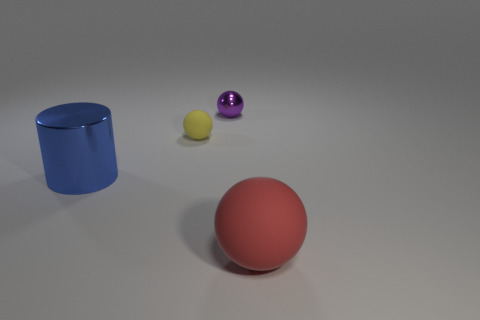Add 1 cyan cylinders. How many objects exist? 5 Subtract all rubber balls. How many balls are left? 1 Subtract all spheres. How many objects are left? 1 Add 1 metal things. How many metal things exist? 3 Subtract 0 purple blocks. How many objects are left? 4 Subtract all big balls. Subtract all cyan rubber cylinders. How many objects are left? 3 Add 4 large rubber balls. How many large rubber balls are left? 5 